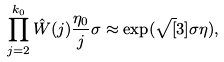Convert formula to latex. <formula><loc_0><loc_0><loc_500><loc_500>\prod _ { j = 2 } ^ { k _ { 0 } } \hat { W } ( j ) \frac { \eta _ { 0 } } { j } \sigma \approx \exp ( \sqrt { [ } 3 ] { \sigma \eta } ) ,</formula> 